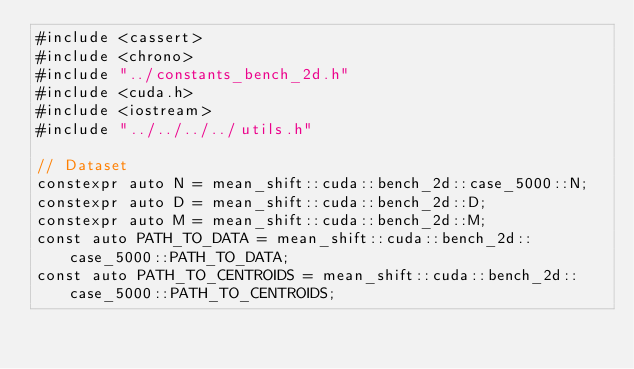<code> <loc_0><loc_0><loc_500><loc_500><_Cuda_>#include <cassert>
#include <chrono>
#include "../constants_bench_2d.h"
#include <cuda.h>
#include <iostream>
#include "../../../../utils.h"

// Dataset
constexpr auto N = mean_shift::cuda::bench_2d::case_5000::N;
constexpr auto D = mean_shift::cuda::bench_2d::D;
constexpr auto M = mean_shift::cuda::bench_2d::M;
const auto PATH_TO_DATA = mean_shift::cuda::bench_2d::case_5000::PATH_TO_DATA; 
const auto PATH_TO_CENTROIDS = mean_shift::cuda::bench_2d::case_5000::PATH_TO_CENTROIDS;</code> 